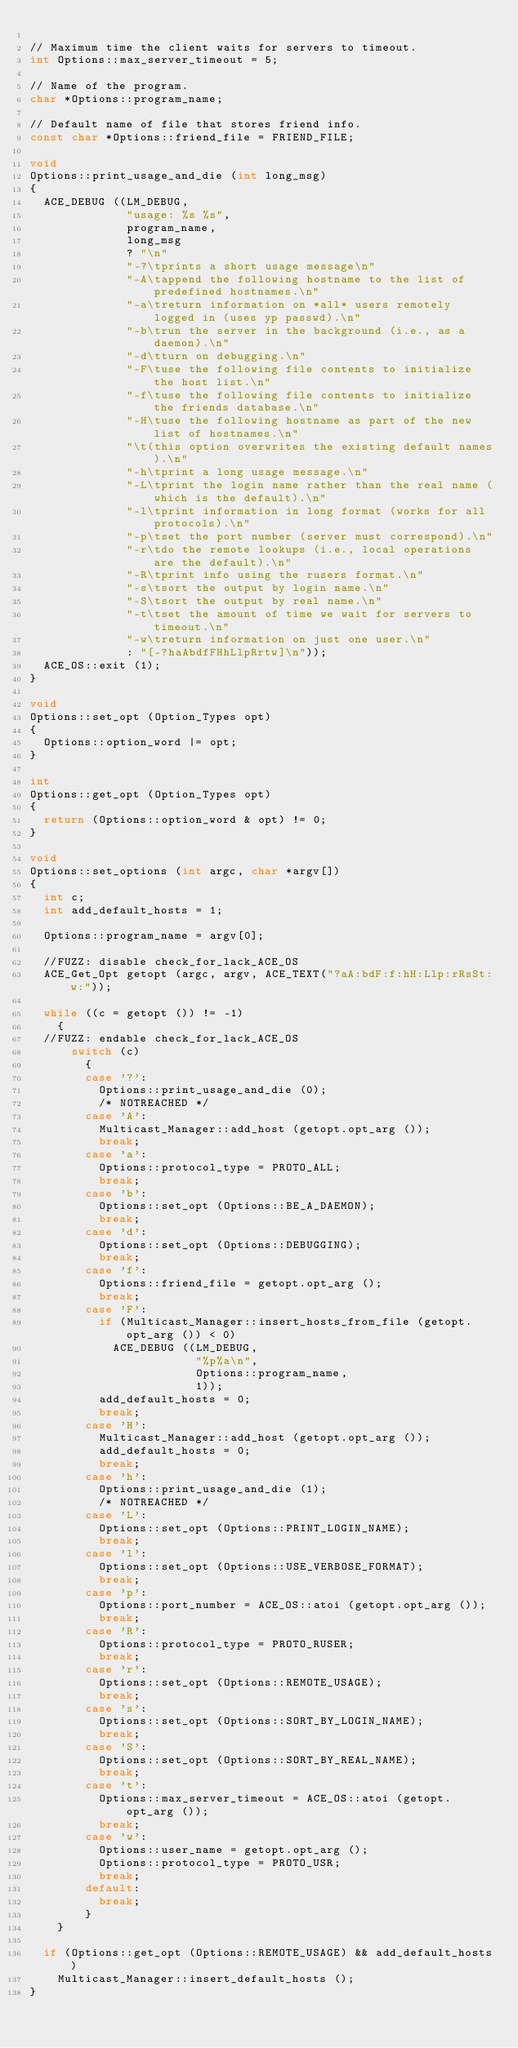Convert code to text. <code><loc_0><loc_0><loc_500><loc_500><_C++_>
// Maximum time the client waits for servers to timeout.
int Options::max_server_timeout = 5;

// Name of the program.
char *Options::program_name;

// Default name of file that stores friend info.
const char *Options::friend_file = FRIEND_FILE;

void
Options::print_usage_and_die (int long_msg)
{
  ACE_DEBUG ((LM_DEBUG,
              "usage: %s %s",
              program_name,
              long_msg
              ? "\n"
              "-?\tprints a short usage message\n"
              "-A\tappend the following hostname to the list of predefined hostnames.\n"
              "-a\treturn information on *all* users remotely logged in (uses yp passwd).\n"
              "-b\trun the server in the background (i.e., as a daemon).\n"
              "-d\tturn on debugging.\n"
              "-F\tuse the following file contents to initialize the host list.\n"
              "-f\tuse the following file contents to initialize the friends database.\n"
              "-H\tuse the following hostname as part of the new list of hostnames.\n"
              "\t(this option overwrites the existing default names).\n"
              "-h\tprint a long usage message.\n"
              "-L\tprint the login name rather than the real name (which is the default).\n"
              "-l\tprint information in long format (works for all protocols).\n"
              "-p\tset the port number (server must correspond).\n"
              "-r\tdo the remote lookups (i.e., local operations are the default).\n"
              "-R\tprint info using the rusers format.\n"
              "-s\tsort the output by login name.\n"
              "-S\tsort the output by real name.\n"
              "-t\tset the amount of time we wait for servers to timeout.\n"
              "-w\treturn information on just one user.\n"
              : "[-?haAbdfFHhLlpRrtw]\n"));
  ACE_OS::exit (1);
}

void
Options::set_opt (Option_Types opt)
{
  Options::option_word |= opt;
}

int
Options::get_opt (Option_Types opt)
{
  return (Options::option_word & opt) != 0;
}

void
Options::set_options (int argc, char *argv[])
{
  int c;
  int add_default_hosts = 1;

  Options::program_name = argv[0];

  //FUZZ: disable check_for_lack_ACE_OS
  ACE_Get_Opt getopt (argc, argv, ACE_TEXT("?aA:bdF:f:hH:Llp:rRsSt:w:"));

  while ((c = getopt ()) != -1)
    {
  //FUZZ: endable check_for_lack_ACE_OS
      switch (c)
        {
        case '?':
          Options::print_usage_and_die (0);
          /* NOTREACHED */
        case 'A':
          Multicast_Manager::add_host (getopt.opt_arg ());
          break;
        case 'a':
          Options::protocol_type = PROTO_ALL;
          break;
        case 'b':
          Options::set_opt (Options::BE_A_DAEMON);
          break;
        case 'd':
          Options::set_opt (Options::DEBUGGING);
          break;
        case 'f':
          Options::friend_file = getopt.opt_arg ();
          break;
        case 'F':
          if (Multicast_Manager::insert_hosts_from_file (getopt.opt_arg ()) < 0)
            ACE_DEBUG ((LM_DEBUG,
                        "%p%a\n",
                        Options::program_name,
                        1));
          add_default_hosts = 0;
          break;
        case 'H':
          Multicast_Manager::add_host (getopt.opt_arg ());
          add_default_hosts = 0;
          break;
        case 'h':
          Options::print_usage_and_die (1);
          /* NOTREACHED */
        case 'L':
          Options::set_opt (Options::PRINT_LOGIN_NAME);
          break;
        case 'l':
          Options::set_opt (Options::USE_VERBOSE_FORMAT);
          break;
        case 'p':
          Options::port_number = ACE_OS::atoi (getopt.opt_arg ());
          break;
        case 'R':
          Options::protocol_type = PROTO_RUSER;
          break;
        case 'r':
          Options::set_opt (Options::REMOTE_USAGE);
          break;
        case 's':
          Options::set_opt (Options::SORT_BY_LOGIN_NAME);
          break;
        case 'S':
          Options::set_opt (Options::SORT_BY_REAL_NAME);
          break;
        case 't':
          Options::max_server_timeout = ACE_OS::atoi (getopt.opt_arg ());
          break;
        case 'w':
          Options::user_name = getopt.opt_arg ();
          Options::protocol_type = PROTO_USR;
          break;
        default:
          break;
        }
    }

  if (Options::get_opt (Options::REMOTE_USAGE) && add_default_hosts)
    Multicast_Manager::insert_default_hosts ();
}
</code> 